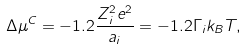<formula> <loc_0><loc_0><loc_500><loc_500>\Delta \mu ^ { C } = - 1 . 2 \frac { Z _ { i } ^ { 2 } e ^ { 2 } } { a _ { i } } = - 1 . 2 \Gamma _ { i } k _ { B } T ,</formula> 